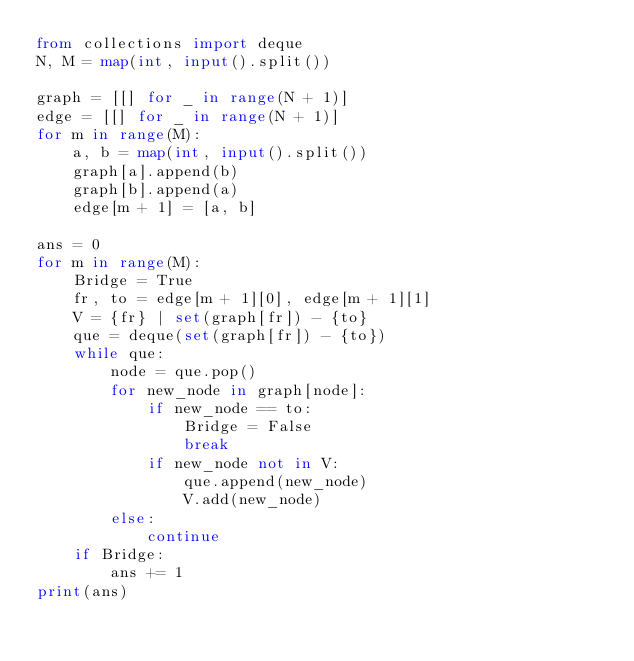Convert code to text. <code><loc_0><loc_0><loc_500><loc_500><_Python_>from collections import deque
N, M = map(int, input().split())

graph = [[] for _ in range(N + 1)]
edge = [[] for _ in range(N + 1)]
for m in range(M):
    a, b = map(int, input().split())
    graph[a].append(b)
    graph[b].append(a)
    edge[m + 1] = [a, b]

ans = 0
for m in range(M):
    Bridge = True
    fr, to = edge[m + 1][0], edge[m + 1][1]
    V = {fr} | set(graph[fr]) - {to}
    que = deque(set(graph[fr]) - {to})
    while que:
        node = que.pop()
        for new_node in graph[node]:
            if new_node == to:
                Bridge = False
                break
            if new_node not in V:
                que.append(new_node)
                V.add(new_node)
        else:
            continue
    if Bridge:
        ans += 1
print(ans)</code> 